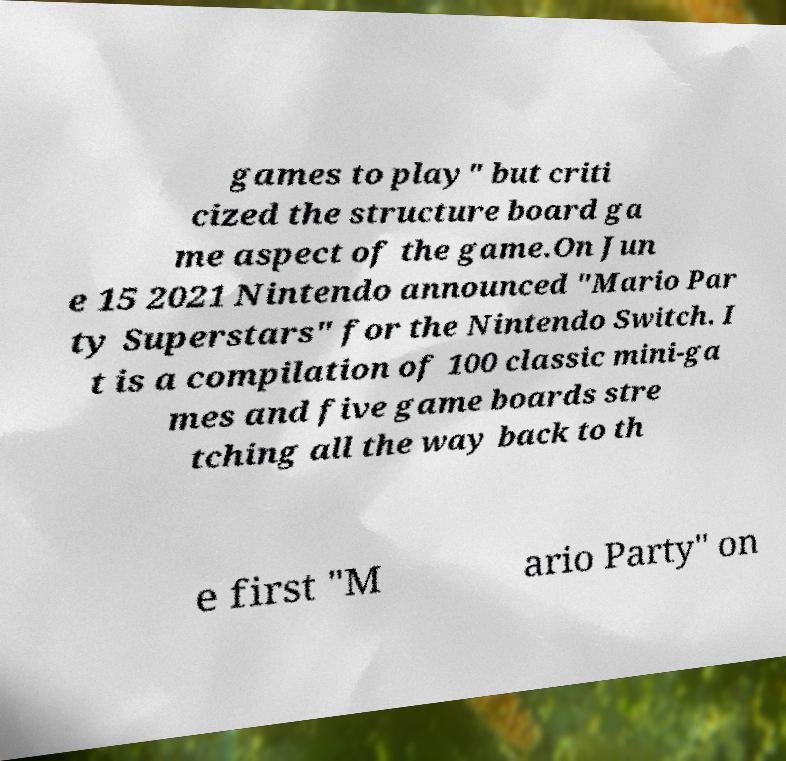Could you assist in decoding the text presented in this image and type it out clearly? games to play" but criti cized the structure board ga me aspect of the game.On Jun e 15 2021 Nintendo announced "Mario Par ty Superstars" for the Nintendo Switch. I t is a compilation of 100 classic mini-ga mes and five game boards stre tching all the way back to th e first "M ario Party" on 